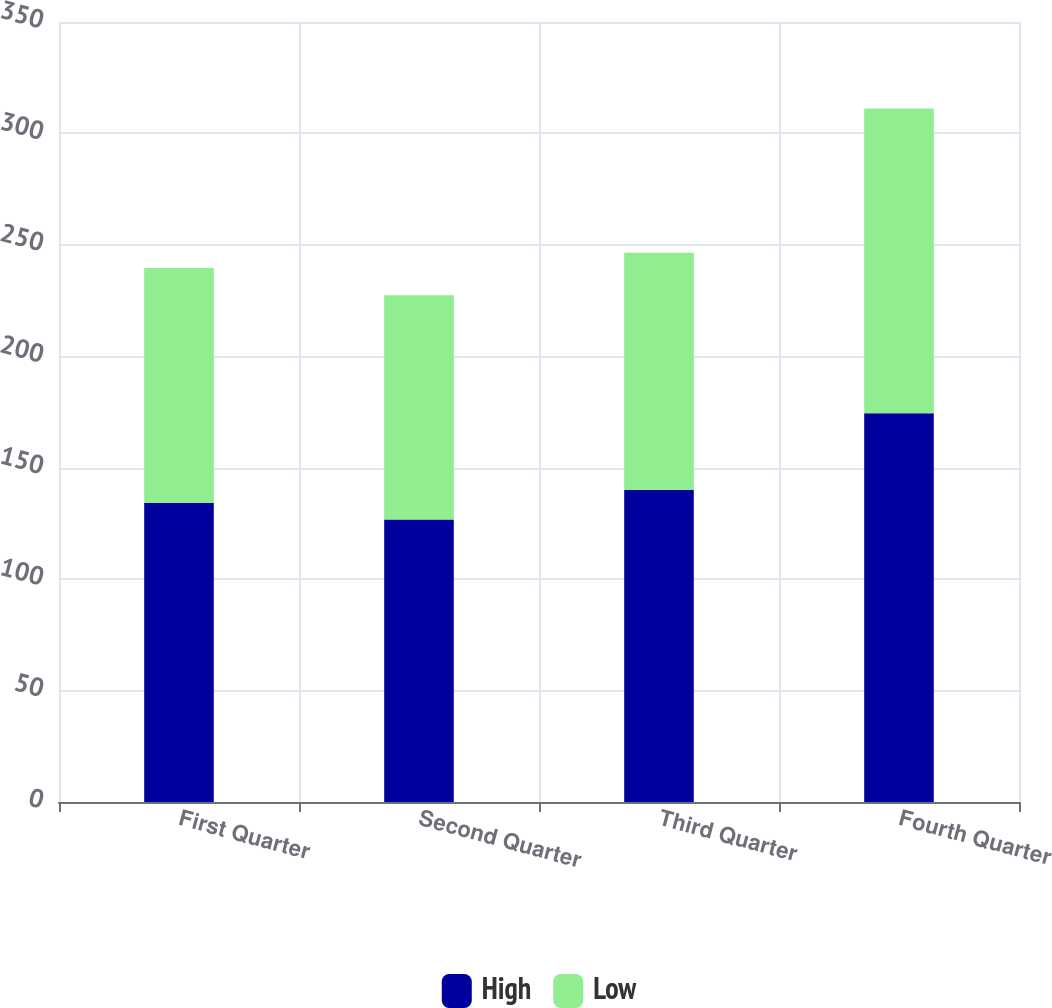Convert chart. <chart><loc_0><loc_0><loc_500><loc_500><stacked_bar_chart><ecel><fcel>First Quarter<fcel>Second Quarter<fcel>Third Quarter<fcel>Fourth Quarter<nl><fcel>High<fcel>134.28<fcel>126.77<fcel>139.98<fcel>174.4<nl><fcel>Low<fcel>105.33<fcel>100.62<fcel>106.52<fcel>136.84<nl></chart> 